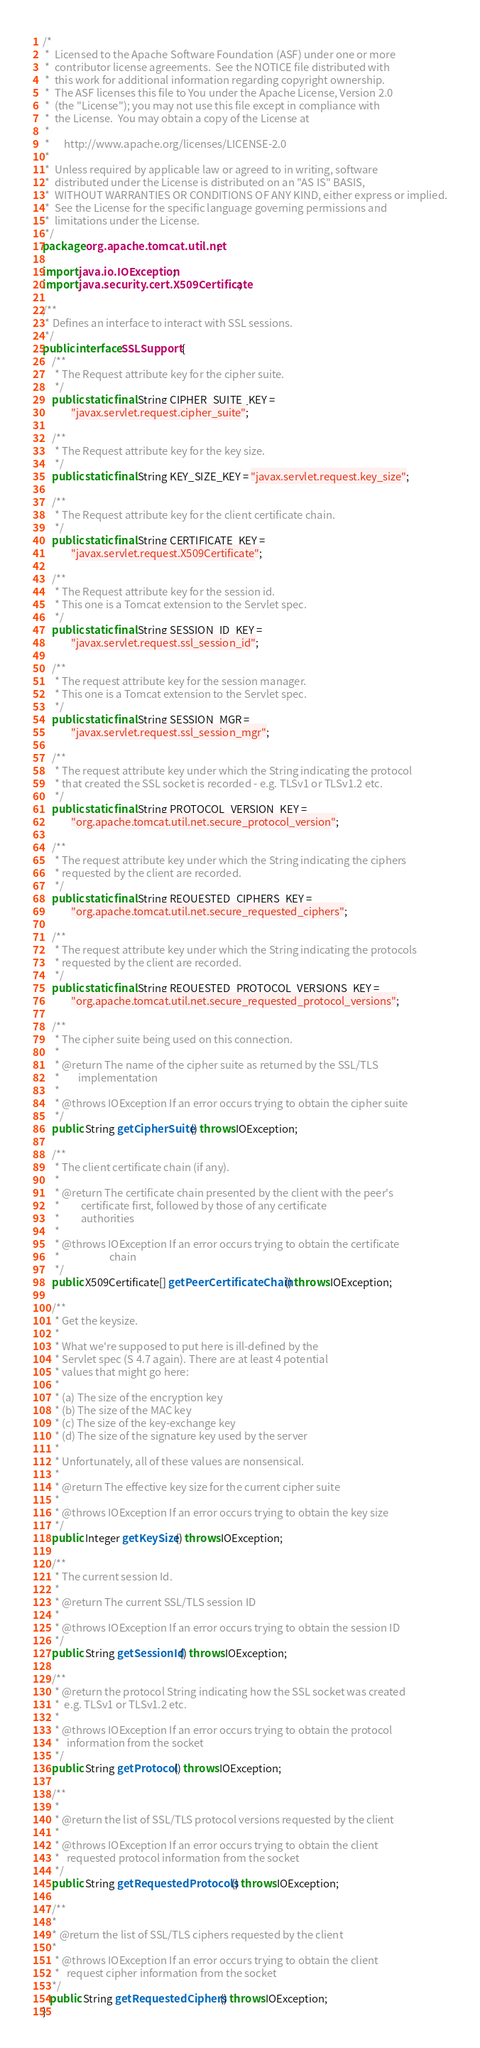<code> <loc_0><loc_0><loc_500><loc_500><_Java_>/*
 *  Licensed to the Apache Software Foundation (ASF) under one or more
 *  contributor license agreements.  See the NOTICE file distributed with
 *  this work for additional information regarding copyright ownership.
 *  The ASF licenses this file to You under the Apache License, Version 2.0
 *  (the "License"); you may not use this file except in compliance with
 *  the License.  You may obtain a copy of the License at
 *
 *      http://www.apache.org/licenses/LICENSE-2.0
 *
 *  Unless required by applicable law or agreed to in writing, software
 *  distributed under the License is distributed on an "AS IS" BASIS,
 *  WITHOUT WARRANTIES OR CONDITIONS OF ANY KIND, either express or implied.
 *  See the License for the specific language governing permissions and
 *  limitations under the License.
 */
package org.apache.tomcat.util.net;

import java.io.IOException;
import java.security.cert.X509Certificate;

/**
 * Defines an interface to interact with SSL sessions.
 */
public interface SSLSupport {
    /**
     * The Request attribute key for the cipher suite.
     */
    public static final String CIPHER_SUITE_KEY =
            "javax.servlet.request.cipher_suite";

    /**
     * The Request attribute key for the key size.
     */
    public static final String KEY_SIZE_KEY = "javax.servlet.request.key_size";

    /**
     * The Request attribute key for the client certificate chain.
     */
    public static final String CERTIFICATE_KEY =
            "javax.servlet.request.X509Certificate";

    /**
     * The Request attribute key for the session id.
     * This one is a Tomcat extension to the Servlet spec.
     */
    public static final String SESSION_ID_KEY =
            "javax.servlet.request.ssl_session_id";

    /**
     * The request attribute key for the session manager.
     * This one is a Tomcat extension to the Servlet spec.
     */
    public static final String SESSION_MGR =
            "javax.servlet.request.ssl_session_mgr";

    /**
     * The request attribute key under which the String indicating the protocol
     * that created the SSL socket is recorded - e.g. TLSv1 or TLSv1.2 etc.
     */
    public static final String PROTOCOL_VERSION_KEY =
            "org.apache.tomcat.util.net.secure_protocol_version";

    /**
     * The request attribute key under which the String indicating the ciphers
     * requested by the client are recorded.
     */
    public static final String REQUESTED_CIPHERS_KEY =
            "org.apache.tomcat.util.net.secure_requested_ciphers";

    /**
     * The request attribute key under which the String indicating the protocols
     * requested by the client are recorded.
     */
    public static final String REQUESTED_PROTOCOL_VERSIONS_KEY =
            "org.apache.tomcat.util.net.secure_requested_protocol_versions";

    /**
     * The cipher suite being used on this connection.
     *
     * @return The name of the cipher suite as returned by the SSL/TLS
     *        implementation
     *
     * @throws IOException If an error occurs trying to obtain the cipher suite
     */
    public String getCipherSuite() throws IOException;

    /**
     * The client certificate chain (if any).
     *
     * @return The certificate chain presented by the client with the peer's
     *         certificate first, followed by those of any certificate
     *         authorities
     *
     * @throws IOException If an error occurs trying to obtain the certificate
     *                     chain
     */
    public X509Certificate[] getPeerCertificateChain() throws IOException;

    /**
     * Get the keysize.
     *
     * What we're supposed to put here is ill-defined by the
     * Servlet spec (S 4.7 again). There are at least 4 potential
     * values that might go here:
     *
     * (a) The size of the encryption key
     * (b) The size of the MAC key
     * (c) The size of the key-exchange key
     * (d) The size of the signature key used by the server
     *
     * Unfortunately, all of these values are nonsensical.
     *
     * @return The effective key size for the current cipher suite
     *
     * @throws IOException If an error occurs trying to obtain the key size
     */
    public Integer getKeySize() throws IOException;

    /**
     * The current session Id.
     *
     * @return The current SSL/TLS session ID
     *
     * @throws IOException If an error occurs trying to obtain the session ID
     */
    public String getSessionId() throws IOException;

    /**
     * @return the protocol String indicating how the SSL socket was created
     *  e.g. TLSv1 or TLSv1.2 etc.
     *
     * @throws IOException If an error occurs trying to obtain the protocol
     *   information from the socket
     */
    public String getProtocol() throws IOException;

    /**
     *
     * @return the list of SSL/TLS protocol versions requested by the client
     *
     * @throws IOException If an error occurs trying to obtain the client
     *   requested protocol information from the socket
     */
    public String getRequestedProtocols() throws IOException;

    /**
    *
    * @return the list of SSL/TLS ciphers requested by the client
    *
     * @throws IOException If an error occurs trying to obtain the client
     *   request cipher information from the socket
    */
   public String getRequestedCiphers() throws IOException;
}
</code> 